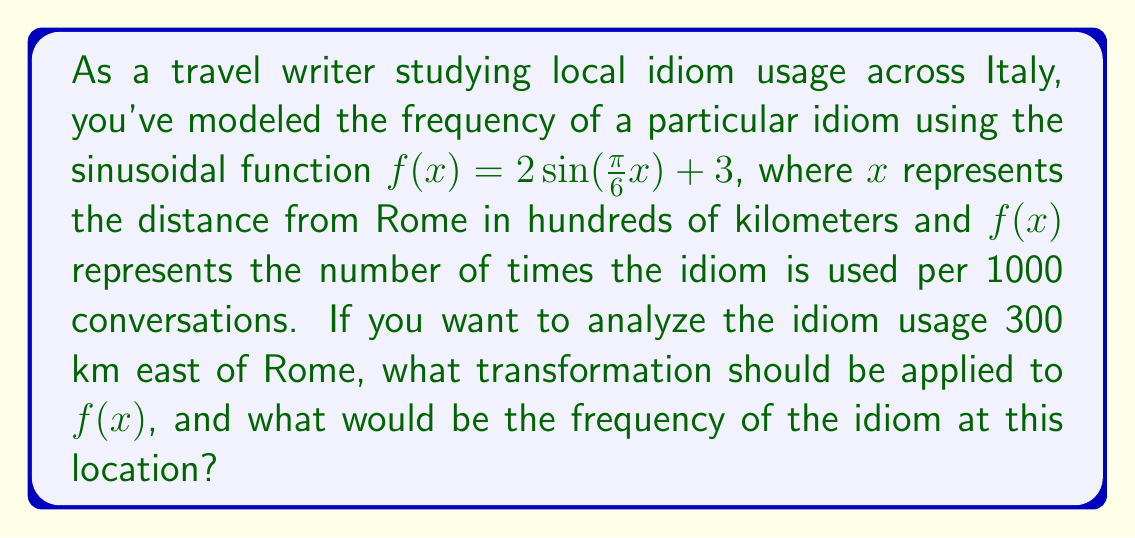Give your solution to this math problem. 1) First, we need to understand what the transformation should be. Since we're moving 300 km east of Rome, and x represents hundreds of kilometers, we need to shift the function 3 units to the left.

2) The general form of a horizontal shift is:
   $f(x) \rightarrow f(x + h)$, where $h$ is positive for a left shift.

3) In this case, $h = 3$, so our transformed function will be:
   $g(x) = 2\sin(\frac{\pi}{6}(x + 3)) + 3$

4) To find the frequency at this location, we need to evaluate $g(0)$, because the point we're interested in (300 km east of Rome) is now at the origin of our transformed function.

5) Let's calculate:
   $g(0) = 2\sin(\frac{\pi}{6}(0 + 3)) + 3$
         $= 2\sin(\frac{\pi}{2}) + 3$
         $= 2(1) + 3$
         $= 5$

6) Therefore, the frequency of the idiom 300 km east of Rome is 5 times per 1000 conversations.
Answer: Left shift by 3 units; 5 times per 1000 conversations 